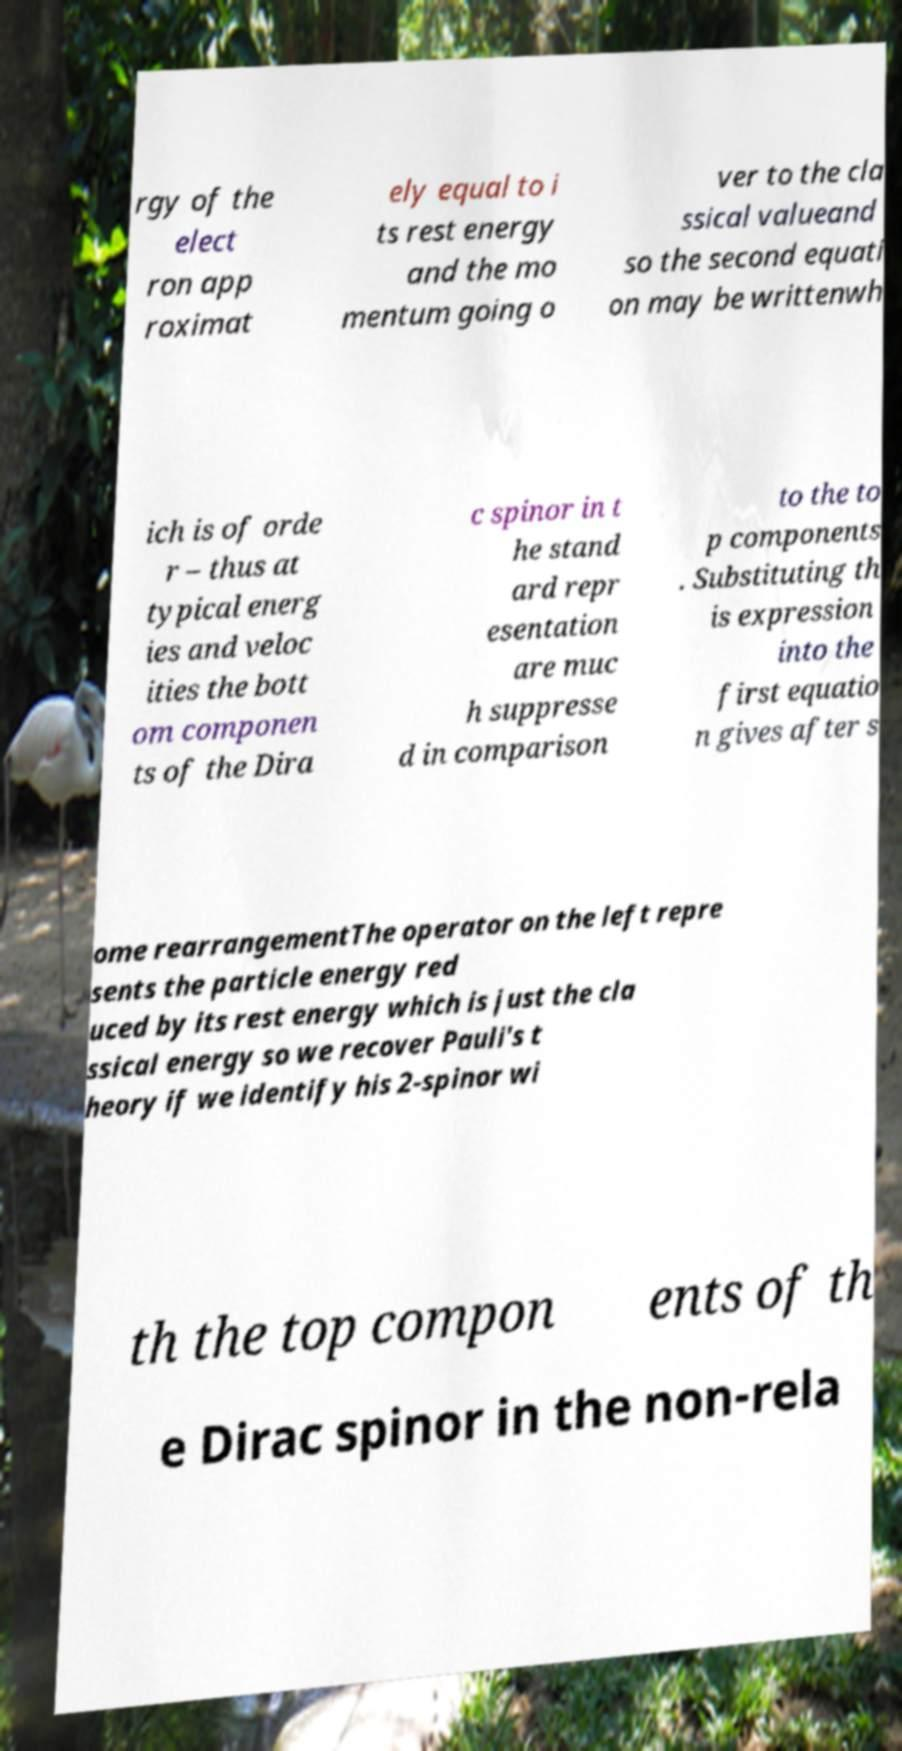I need the written content from this picture converted into text. Can you do that? rgy of the elect ron app roximat ely equal to i ts rest energy and the mo mentum going o ver to the cla ssical valueand so the second equati on may be writtenwh ich is of orde r – thus at typical energ ies and veloc ities the bott om componen ts of the Dira c spinor in t he stand ard repr esentation are muc h suppresse d in comparison to the to p components . Substituting th is expression into the first equatio n gives after s ome rearrangementThe operator on the left repre sents the particle energy red uced by its rest energy which is just the cla ssical energy so we recover Pauli's t heory if we identify his 2-spinor wi th the top compon ents of th e Dirac spinor in the non-rela 